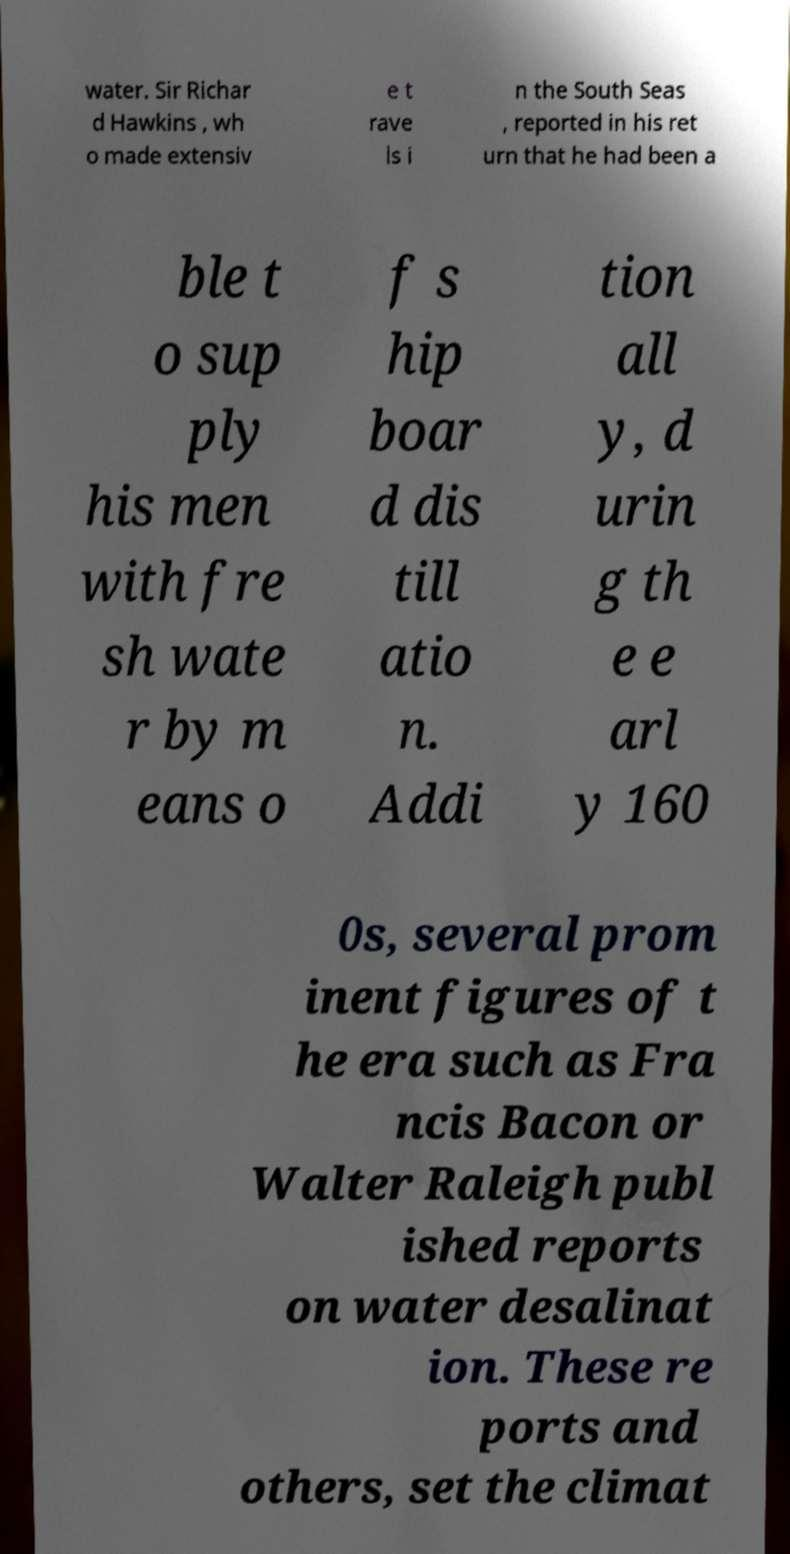Please identify and transcribe the text found in this image. water. Sir Richar d Hawkins , wh o made extensiv e t rave ls i n the South Seas , reported in his ret urn that he had been a ble t o sup ply his men with fre sh wate r by m eans o f s hip boar d dis till atio n. Addi tion all y, d urin g th e e arl y 160 0s, several prom inent figures of t he era such as Fra ncis Bacon or Walter Raleigh publ ished reports on water desalinat ion. These re ports and others, set the climat 